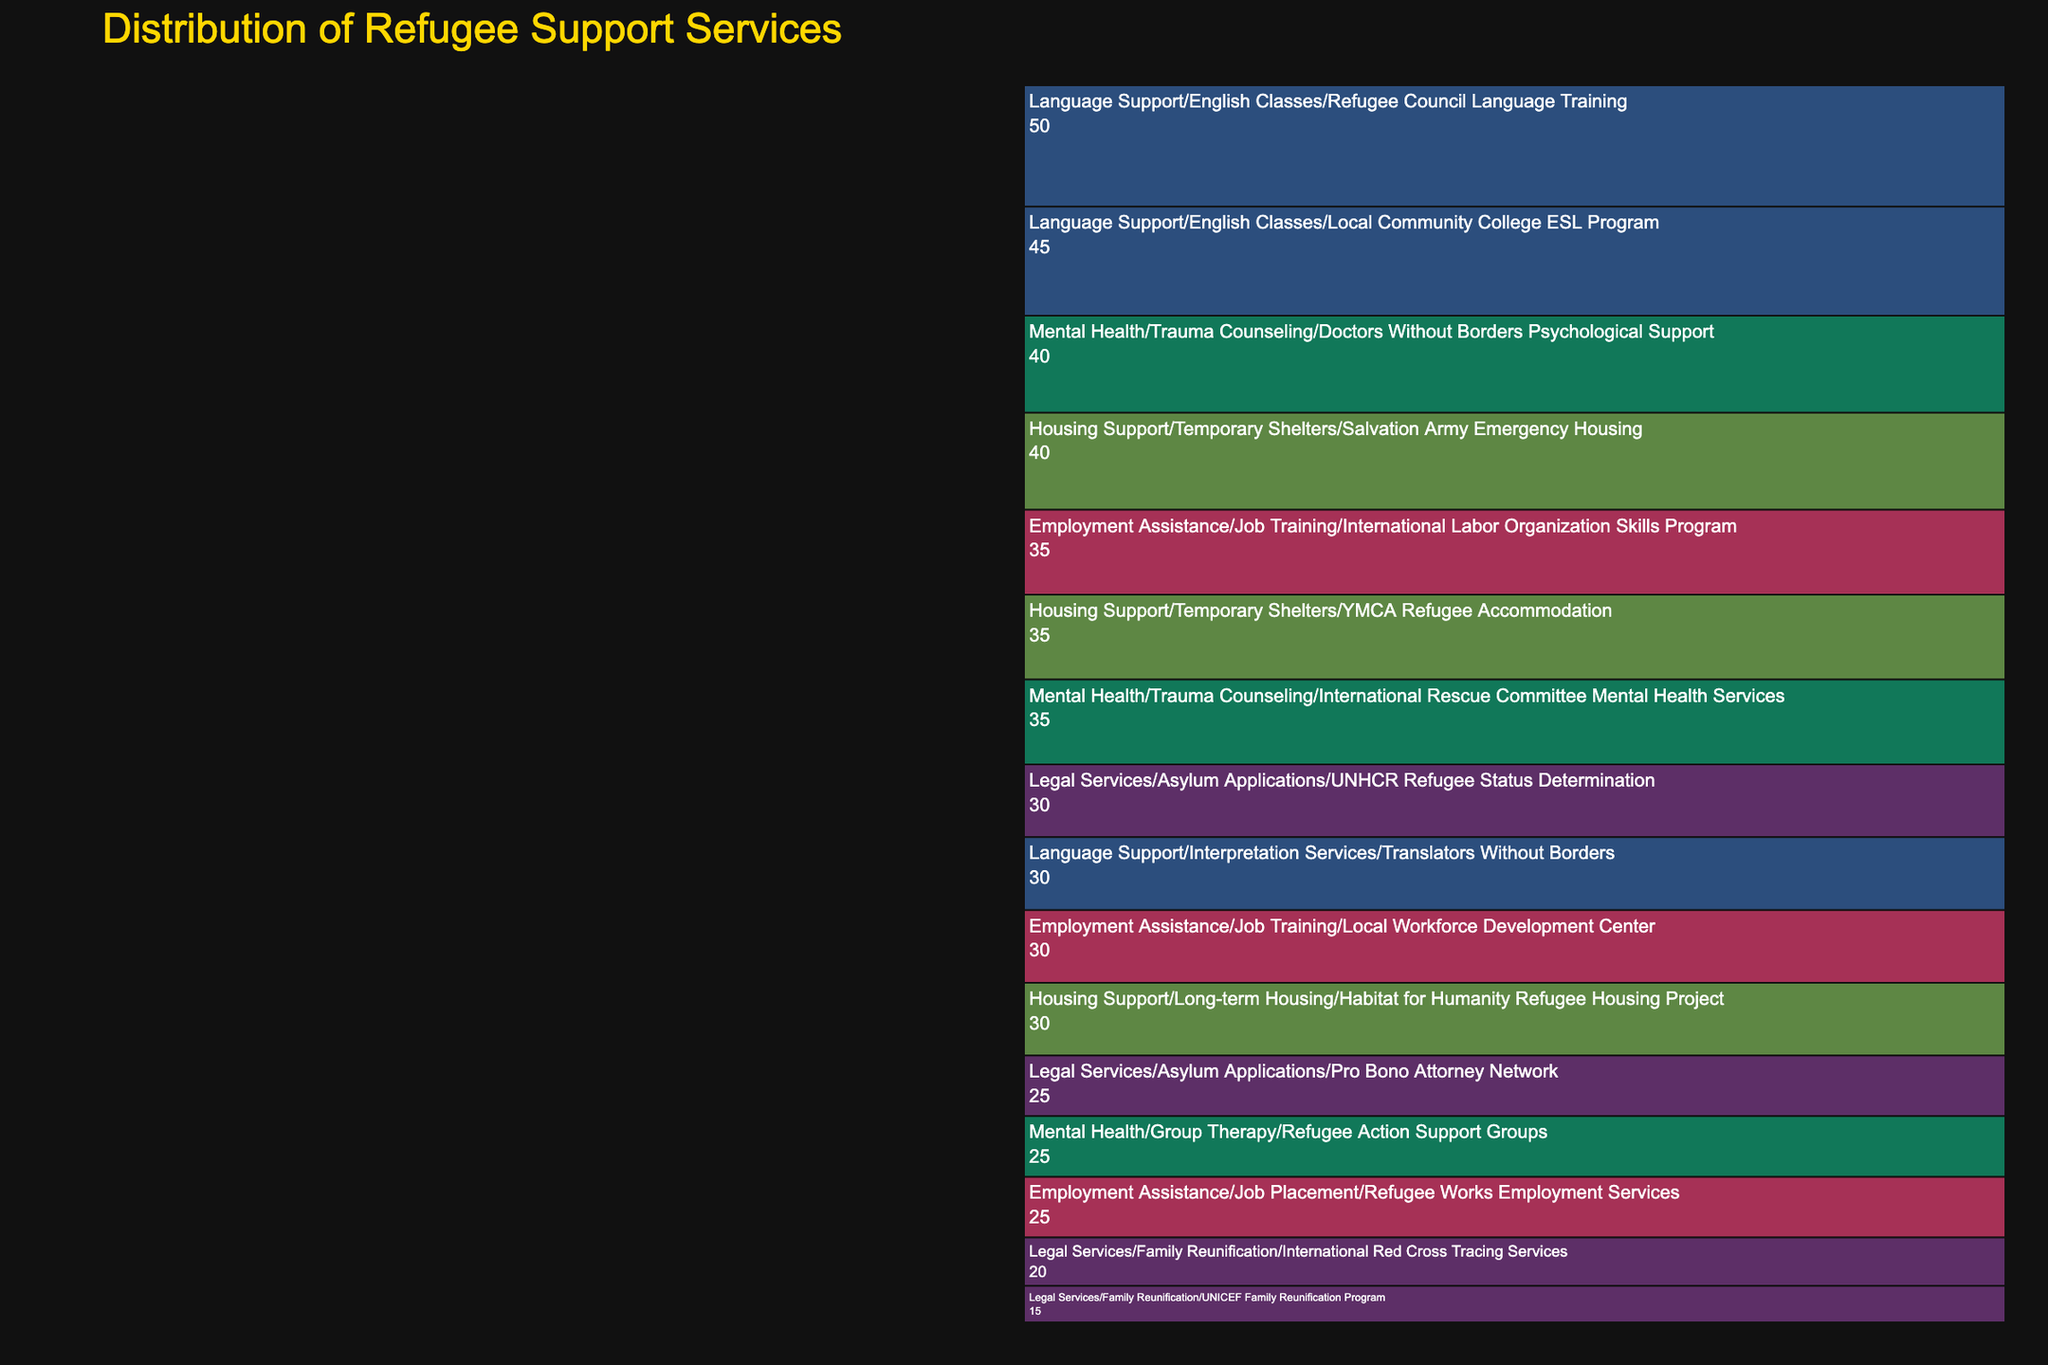What is the title of the chart? The title of the chart is displayed prominently at the top of the figure. It provides a concise summary of the data presented in the chart.
Answer: Distribution of Refugee Support Services Which program under Legal Services has the highest value? Looking under the 'Legal Services' category and finding the 'Asylum Applications' subcategory, we see two programs. The 'UNHCR Refugee Status Determination' program has a value of 30, which is higher than the other programs in Legal Services.
Answer: UNHCR Refugee Status Determination Which category has the most considerable total value? We look at the total values accumulated under each category. Adding up all subcategory values, we see that the 'Mental Health' category has the highest values with 40 + 35 + 25 = 100.
Answer: Mental Health In the 'Employment Assistance' category, which subcategory has a higher total value, Job Training or Job Placement? Adding up the values for 'Job Training' subcategory (35 + 30 = 65) and comparing it with 'Job Placement' (25), Job Training has a higher total value.
Answer: Job Training What is the combined value for all programs under Housing Support? To find the total for Housing Support, sum the values of its programs: 40 (Salvation Army Emergency Housing) + 35 (YMCA Refugee Accommodation) + 30 (Habitat for Humanity Refugee Housing Project) = 105.
Answer: 105 Which category has the program with the highest individual value? By examining each category, we see that the highest value for an individual program is 50 (Refugee Council Language Training), which falls under 'Language Support'.
Answer: Language Support What is the percentage share of Language Support's 'English Classes' programs compared to the total value of all services? First, find the total value of 'English Classes' (50 + 45 = 95). The total value for all categories summed together is the sum of all values mentioned which is 510. The percentage share is (95 / 510) * 100 ≈ 18.63%.
Answer: 18.63% How many subcategories are there under Legal Services? Under the 'Legal Services' category, there are two distinct subcategories: 'Asylum Applications' and 'Family Reunification'.
Answer: 2 Which service category has the least representation in terms of programs? By counting the programs in each category, 'Housing Support' has just 3 programs, which is the least compared to others.
Answer: Housing Support 